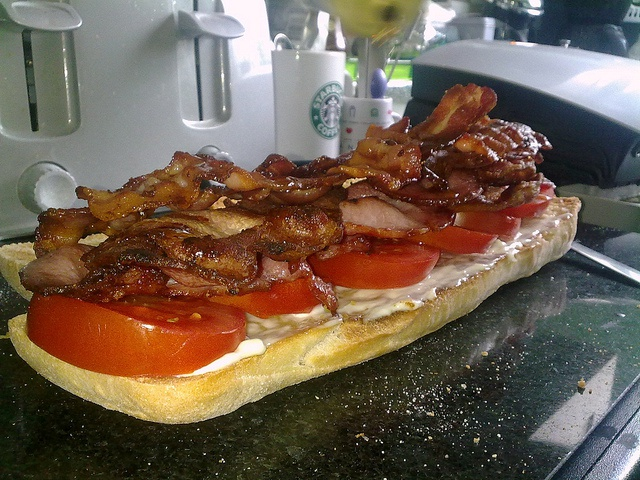Describe the objects in this image and their specific colors. I can see sandwich in gray, maroon, brown, and black tones, cup in gray, darkgray, and lightgray tones, vase in gray and lavender tones, and spoon in gray, white, darkgray, and lightgray tones in this image. 